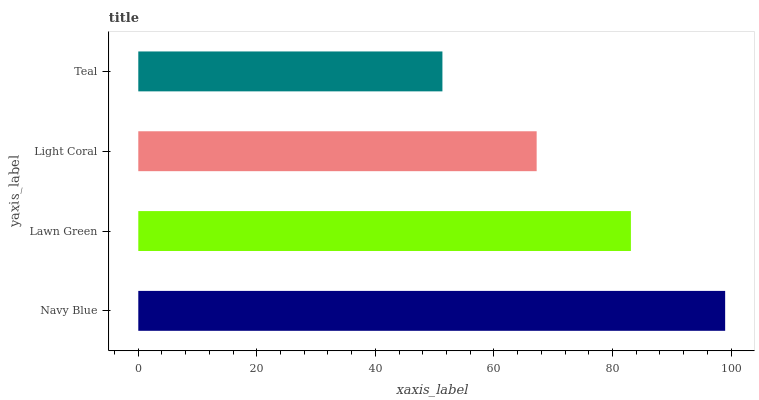Is Teal the minimum?
Answer yes or no. Yes. Is Navy Blue the maximum?
Answer yes or no. Yes. Is Lawn Green the minimum?
Answer yes or no. No. Is Lawn Green the maximum?
Answer yes or no. No. Is Navy Blue greater than Lawn Green?
Answer yes or no. Yes. Is Lawn Green less than Navy Blue?
Answer yes or no. Yes. Is Lawn Green greater than Navy Blue?
Answer yes or no. No. Is Navy Blue less than Lawn Green?
Answer yes or no. No. Is Lawn Green the high median?
Answer yes or no. Yes. Is Light Coral the low median?
Answer yes or no. Yes. Is Light Coral the high median?
Answer yes or no. No. Is Teal the low median?
Answer yes or no. No. 